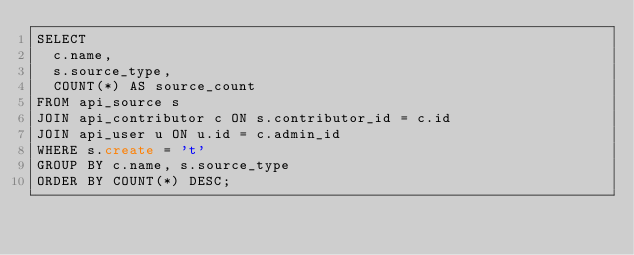<code> <loc_0><loc_0><loc_500><loc_500><_SQL_>SELECT
  c.name,
  s.source_type,
  COUNT(*) AS source_count
FROM api_source s
JOIN api_contributor c ON s.contributor_id = c.id
JOIN api_user u ON u.id = c.admin_id
WHERE s.create = 't'
GROUP BY c.name, s.source_type
ORDER BY COUNT(*) DESC;
</code> 